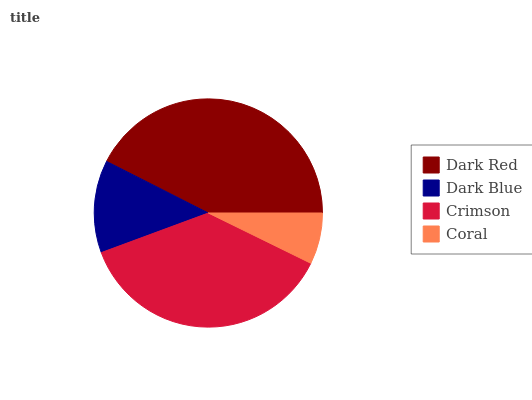Is Coral the minimum?
Answer yes or no. Yes. Is Dark Red the maximum?
Answer yes or no. Yes. Is Dark Blue the minimum?
Answer yes or no. No. Is Dark Blue the maximum?
Answer yes or no. No. Is Dark Red greater than Dark Blue?
Answer yes or no. Yes. Is Dark Blue less than Dark Red?
Answer yes or no. Yes. Is Dark Blue greater than Dark Red?
Answer yes or no. No. Is Dark Red less than Dark Blue?
Answer yes or no. No. Is Crimson the high median?
Answer yes or no. Yes. Is Dark Blue the low median?
Answer yes or no. Yes. Is Dark Red the high median?
Answer yes or no. No. Is Crimson the low median?
Answer yes or no. No. 